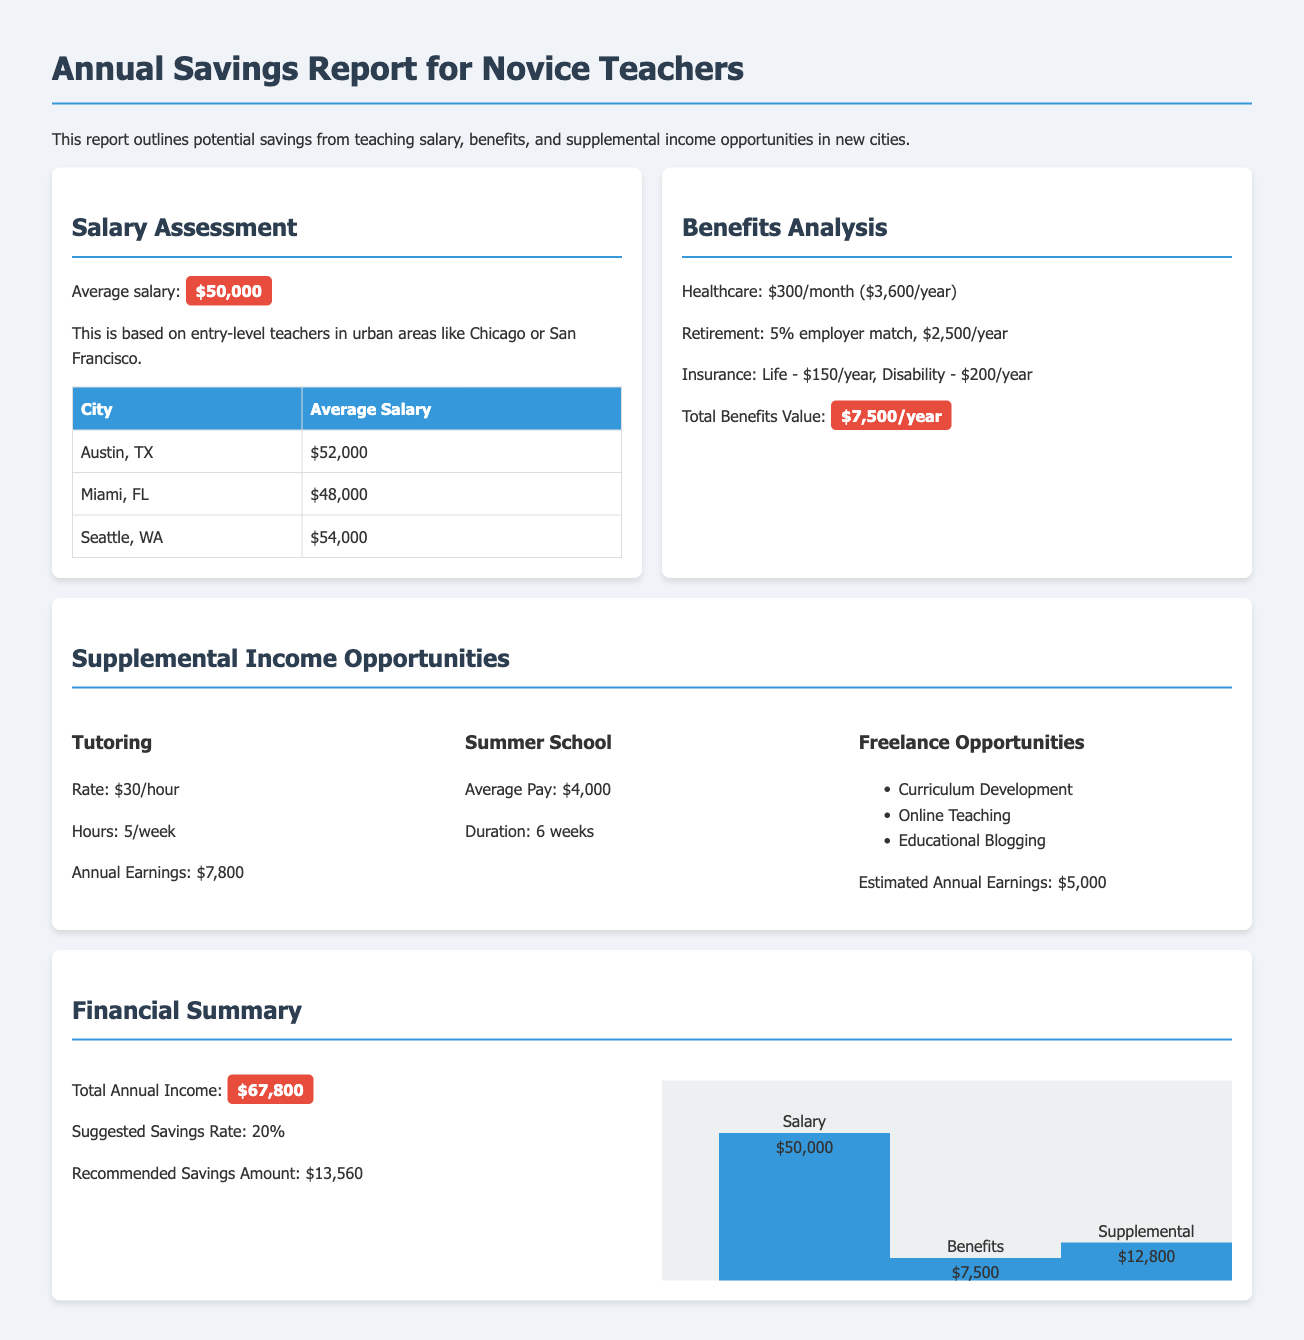What is the average salary for novice teachers? The average salary for novice teachers in urban areas is provided in the report as $50,000.
Answer: $50,000 What is the total value of benefits for teachers? The total value of benefits combines healthcare, retirement, and insurance, amounting to $7,500 per year.
Answer: $7,500 How much can a teacher earn annually through tutoring? Tutoring earnings are listed as $30 per hour for 5 hours a week, resulting in $7,800 per year.
Answer: $7,800 What is the suggested savings rate for novice teachers? The report recommends a savings rate of 20% based on total annual income.
Answer: 20% What is the estimated annual earnings from freelance opportunities? The document states that estimated annual earnings from freelance work are $5,000.
Answer: $5,000 How much can teachers earn from summer school on average? The report specifies that average pay for summer school is $4,000 for a 6-week period.
Answer: $4,000 What is the total annual income calculated for a novice teacher? Total annual income is a summation of salary, benefits, and supplemental income totaling $67,800.
Answer: $67,800 What percentage of the total income is suggested to be saved? The report recommends saving 20% of the total income.
Answer: 20% What is the annual earnings from all supplemental income sources? The combined supplemental income from all sources is summarized as $12,800 in the financial summary.
Answer: $12,800 